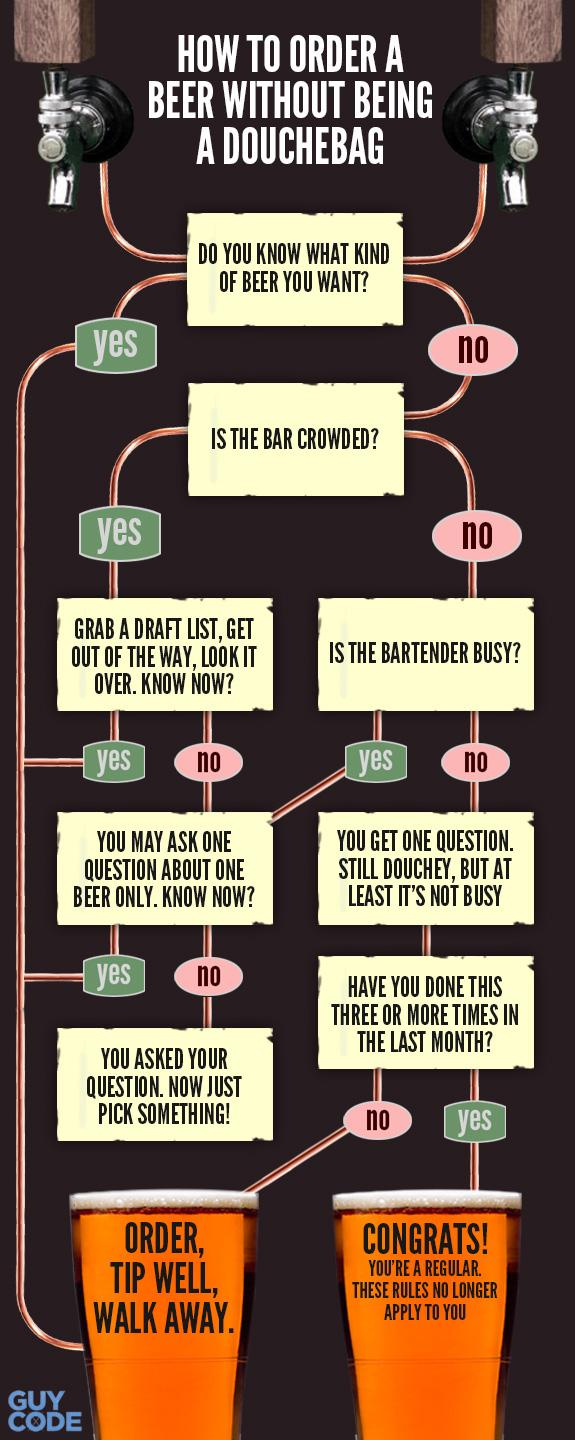Indicate a few pertinent items in this graphic. There are six yes in the image. If you have not performed this task three or more times in the last month, it is necessary to order properly, tip generously, and leave the premises. I am now exempt from these rules because I am a regular. There are two beer glasses being displayed. If I, having decided on the type of beer I desire, order and provide a generous tip, then I will leave the establishment satisfied. 